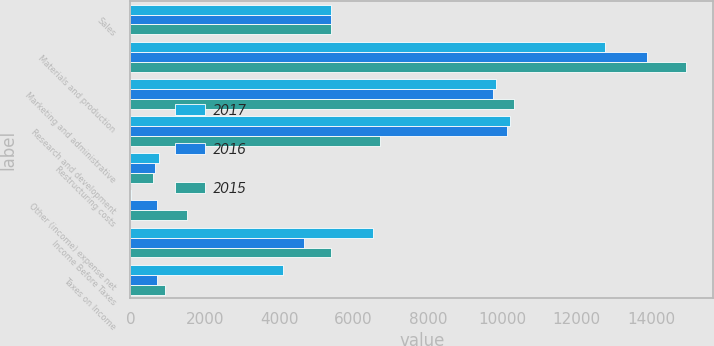Convert chart to OTSL. <chart><loc_0><loc_0><loc_500><loc_500><stacked_bar_chart><ecel><fcel>Sales<fcel>Materials and production<fcel>Marketing and administrative<fcel>Research and development<fcel>Restructuring costs<fcel>Other (income) expense net<fcel>Income Before Taxes<fcel>Taxes on Income<nl><fcel>2017<fcel>5401<fcel>12775<fcel>9830<fcel>10208<fcel>776<fcel>12<fcel>6521<fcel>4103<nl><fcel>2016<fcel>5401<fcel>13891<fcel>9762<fcel>10124<fcel>651<fcel>720<fcel>4659<fcel>718<nl><fcel>2015<fcel>5401<fcel>14934<fcel>10313<fcel>6704<fcel>619<fcel>1527<fcel>5401<fcel>942<nl></chart> 